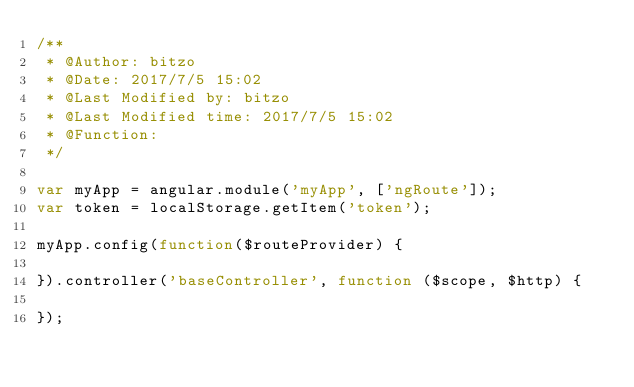<code> <loc_0><loc_0><loc_500><loc_500><_JavaScript_>/**
 * @Author: bitzo
 * @Date: 2017/7/5 15:02
 * @Last Modified by: bitzo
 * @Last Modified time: 2017/7/5 15:02
 * @Function:
 */

var myApp = angular.module('myApp', ['ngRoute']);
var token = localStorage.getItem('token');

myApp.config(function($routeProvider) {

}).controller('baseController', function ($scope, $http) {

});</code> 